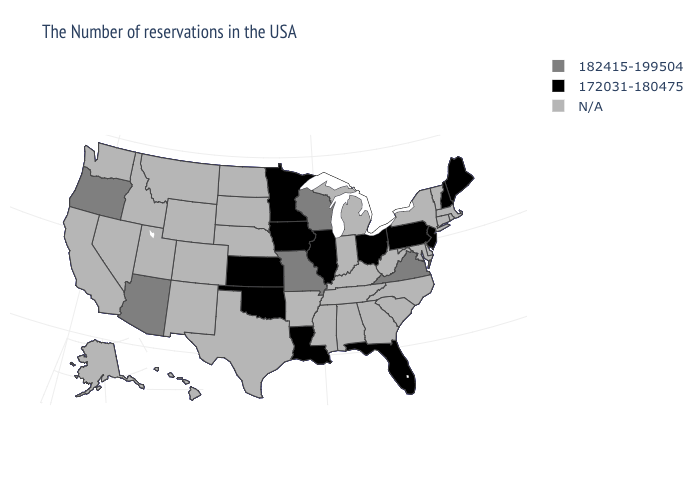Name the states that have a value in the range 172031-180475?
Short answer required. Maine, New Hampshire, New Jersey, Pennsylvania, Ohio, Florida, Illinois, Louisiana, Minnesota, Iowa, Kansas, Oklahoma. Name the states that have a value in the range 182415-199504?
Short answer required. Virginia, Wisconsin, Missouri, Arizona, Oregon. What is the value of Florida?
Give a very brief answer. 172031-180475. Name the states that have a value in the range 172031-180475?
Keep it brief. Maine, New Hampshire, New Jersey, Pennsylvania, Ohio, Florida, Illinois, Louisiana, Minnesota, Iowa, Kansas, Oklahoma. Name the states that have a value in the range N/A?
Write a very short answer. Massachusetts, Rhode Island, Vermont, Connecticut, New York, Delaware, Maryland, North Carolina, South Carolina, West Virginia, Georgia, Michigan, Kentucky, Indiana, Alabama, Tennessee, Mississippi, Arkansas, Nebraska, Texas, South Dakota, North Dakota, Wyoming, Colorado, New Mexico, Utah, Montana, Idaho, Nevada, California, Washington, Alaska, Hawaii. What is the lowest value in the Northeast?
Concise answer only. 172031-180475. Name the states that have a value in the range 172031-180475?
Short answer required. Maine, New Hampshire, New Jersey, Pennsylvania, Ohio, Florida, Illinois, Louisiana, Minnesota, Iowa, Kansas, Oklahoma. Does the map have missing data?
Quick response, please. Yes. What is the value of Minnesota?
Give a very brief answer. 172031-180475. Which states hav the highest value in the West?
Concise answer only. Arizona, Oregon. What is the lowest value in states that border West Virginia?
Short answer required. 172031-180475. 